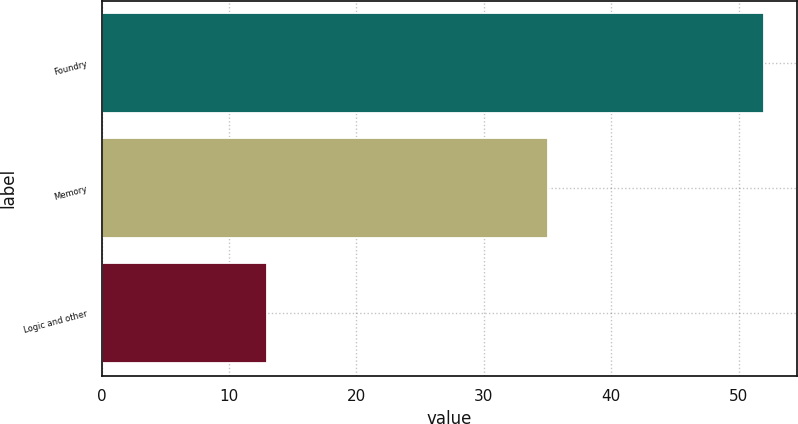Convert chart. <chart><loc_0><loc_0><loc_500><loc_500><bar_chart><fcel>Foundry<fcel>Memory<fcel>Logic and other<nl><fcel>52<fcel>35<fcel>13<nl></chart> 